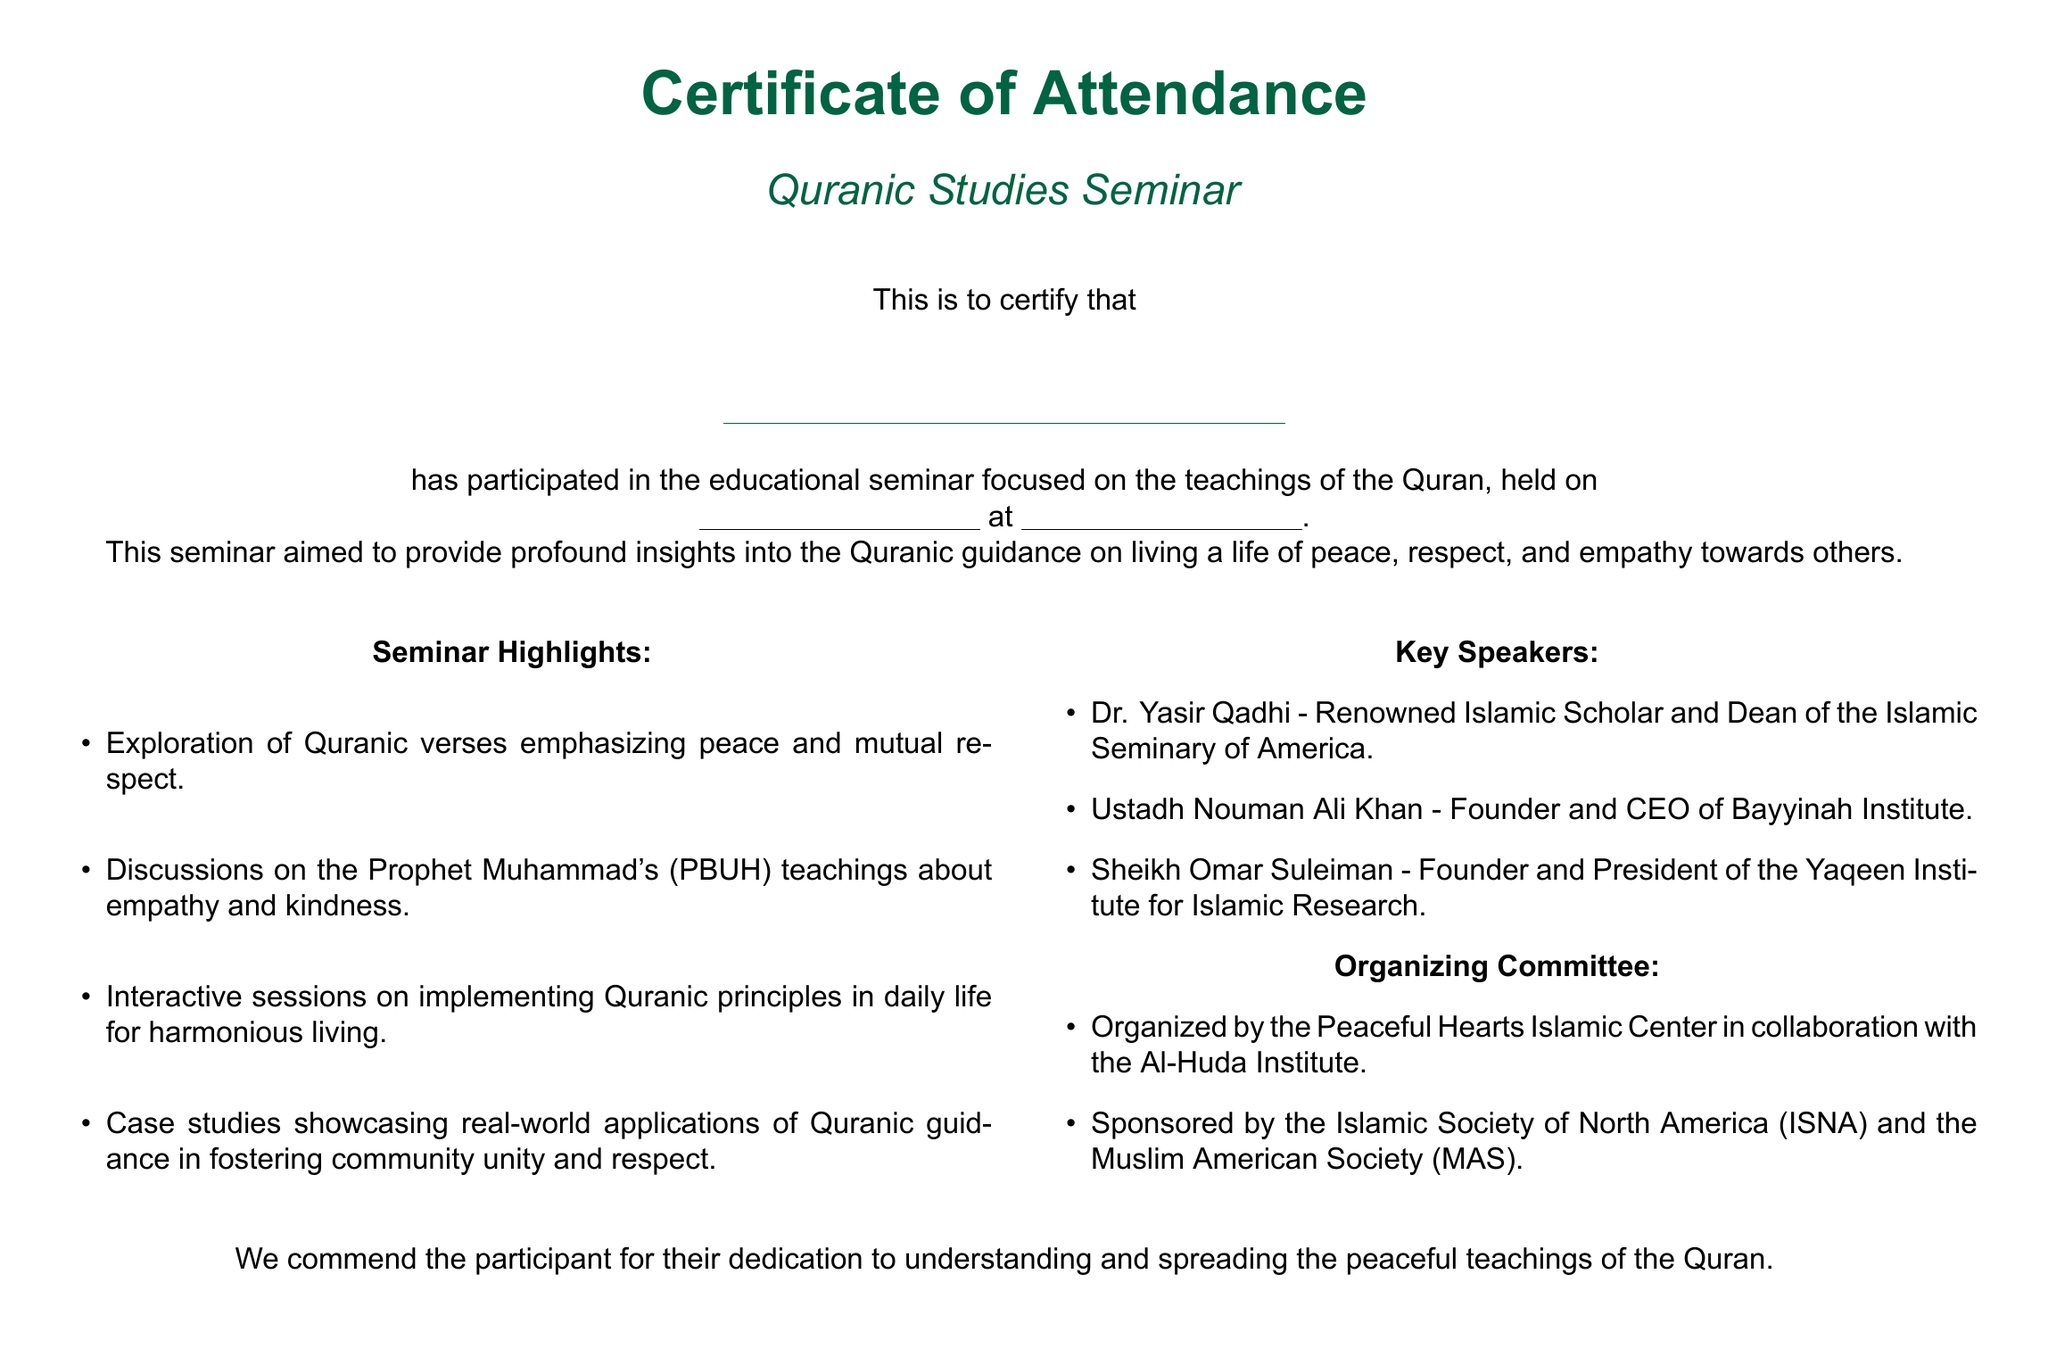What is the title of the seminar? The title of the seminar is stated prominently in the document, which is "Quranic Studies Seminar."
Answer: Quranic Studies Seminar Who organized the seminar? The document lists the organizing committee, which includes the Peaceful Hearts Islamic Center and the Al-Huda Institute.
Answer: Peaceful Hearts Islamic Center What is the date format provided for the seminar? The document includes a space for the date of the seminar, indicating that it will be filled in by the relevant authority.
Answer: Not specified Name a key speaker of the seminar. The document mentions three key speakers, including Dr. Yasir Qadhi, among others.
Answer: Dr. Yasir Qadhi What is one highlight of the seminar? The document provides a list of highlights, and one of them is the "Exploration of Quranic verses emphasizing peace and mutual respect."
Answer: Exploration of Quranic verses emphasizing peace and mutual respect What does the certificate commend the participant for? The certificate commends the participant for their dedication to understanding and spreading the peaceful teachings of the Quran.
Answer: Understanding and spreading the peaceful teachings of the Quran What color is primarily used in the document? The document uses a specific shade, which is referred to as "Islamic green."
Answer: Islamic green Who sponsored the seminar? The document states that the seminar was sponsored by two organizations: the Islamic Society of North America and the Muslim American Society.
Answer: Islamic Society of North America and the Muslim American Society 